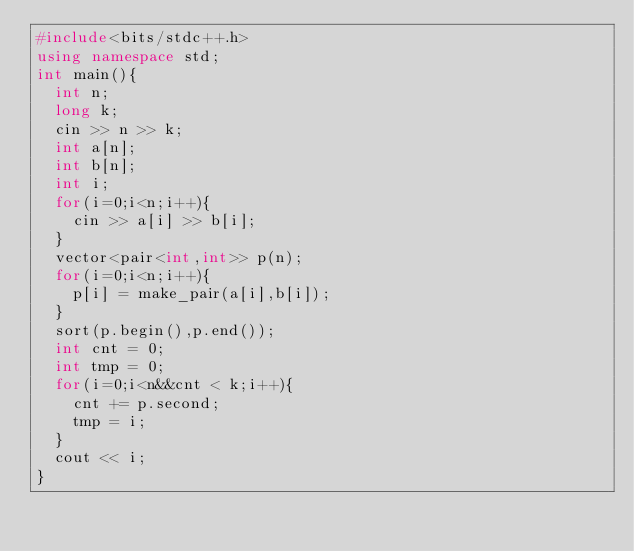Convert code to text. <code><loc_0><loc_0><loc_500><loc_500><_C++_>#include<bits/stdc++.h>
using namespace std;
int main(){
  int n;
  long k;
  cin >> n >> k;
  int a[n];
  int b[n];
  int i;
  for(i=0;i<n;i++){
    cin >> a[i] >> b[i];
  }
  vector<pair<int,int>> p(n);
  for(i=0;i<n;i++){
    p[i] = make_pair(a[i],b[i]);
  }
  sort(p.begin(),p.end());
  int cnt = 0;
  int tmp = 0;
  for(i=0;i<n&&cnt < k;i++){
    cnt += p.second;
    tmp = i;
  }
  cout << i;
}</code> 